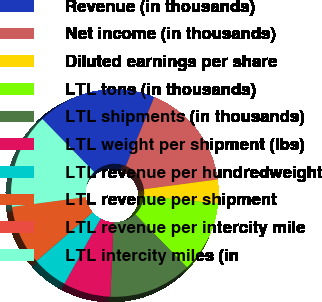<chart> <loc_0><loc_0><loc_500><loc_500><pie_chart><fcel>Revenue (in thousands)<fcel>Net income (in thousands)<fcel>Diluted earnings per share<fcel>LTL tons (in thousands)<fcel>LTL shipments (in thousands)<fcel>LTL weight per shipment (lbs)<fcel>LTL revenue per hundredweight<fcel>LTL revenue per shipment<fcel>LTL revenue per intercity mile<fcel>LTL intercity miles (in<nl><fcel>18.52%<fcel>16.67%<fcel>3.7%<fcel>11.11%<fcel>12.96%<fcel>7.41%<fcel>5.56%<fcel>9.26%<fcel>0.0%<fcel>14.81%<nl></chart> 